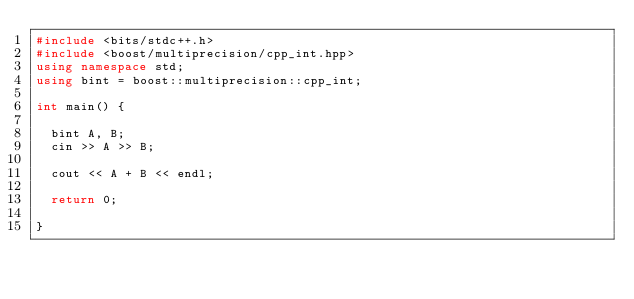Convert code to text. <code><loc_0><loc_0><loc_500><loc_500><_C++_>#include <bits/stdc++.h>
#include <boost/multiprecision/cpp_int.hpp>
using namespace std;
using bint = boost::multiprecision::cpp_int;

int main() {

  bint A, B;
  cin >> A >> B;

  cout << A + B << endl;

  return 0;

}
</code> 